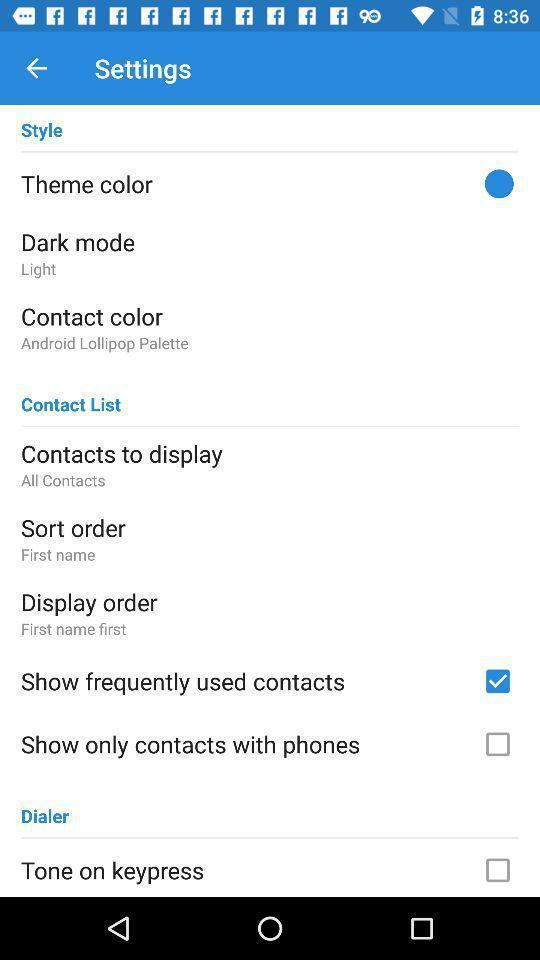Provide a detailed account of this screenshot. Page showing settings options of mobile. 